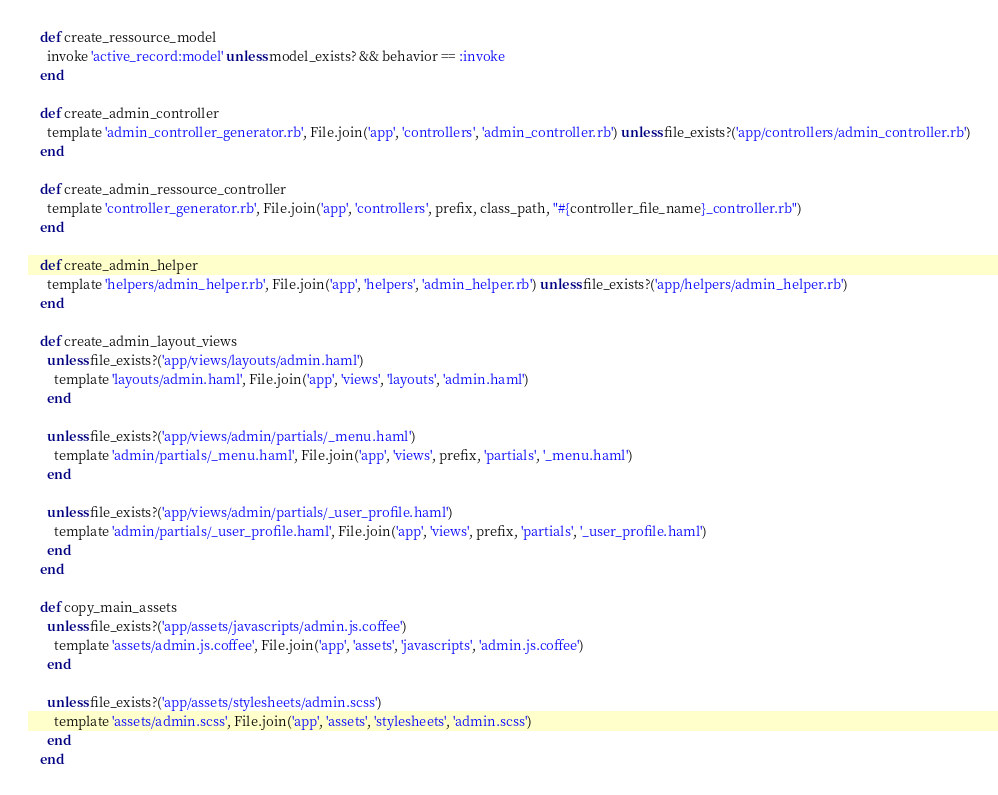Convert code to text. <code><loc_0><loc_0><loc_500><loc_500><_Ruby_>
    def create_ressource_model
      invoke 'active_record:model' unless model_exists? && behavior == :invoke
    end

    def create_admin_controller
      template 'admin_controller_generator.rb', File.join('app', 'controllers', 'admin_controller.rb') unless file_exists?('app/controllers/admin_controller.rb')
    end

    def create_admin_ressource_controller
      template 'controller_generator.rb', File.join('app', 'controllers', prefix, class_path, "#{controller_file_name}_controller.rb")
    end

    def create_admin_helper
      template 'helpers/admin_helper.rb', File.join('app', 'helpers', 'admin_helper.rb') unless file_exists?('app/helpers/admin_helper.rb')
    end

    def create_admin_layout_views
      unless file_exists?('app/views/layouts/admin.haml')
        template 'layouts/admin.haml', File.join('app', 'views', 'layouts', 'admin.haml')
      end

      unless file_exists?('app/views/admin/partials/_menu.haml')
        template 'admin/partials/_menu.haml', File.join('app', 'views', prefix, 'partials', '_menu.haml')
      end

      unless file_exists?('app/views/admin/partials/_user_profile.haml')
        template 'admin/partials/_user_profile.haml', File.join('app', 'views', prefix, 'partials', '_user_profile.haml')
      end
    end

    def copy_main_assets
      unless file_exists?('app/assets/javascripts/admin.js.coffee')
        template 'assets/admin.js.coffee', File.join('app', 'assets', 'javascripts', 'admin.js.coffee')
      end

      unless file_exists?('app/assets/stylesheets/admin.scss')
        template 'assets/admin.scss', File.join('app', 'assets', 'stylesheets', 'admin.scss')
      end
    end
</code> 